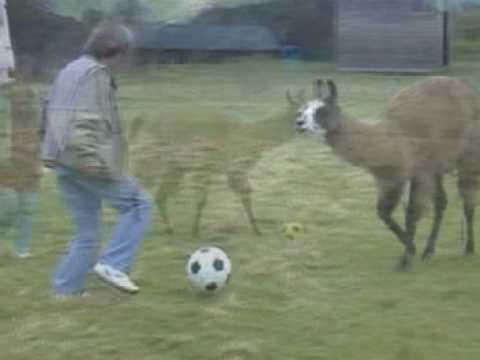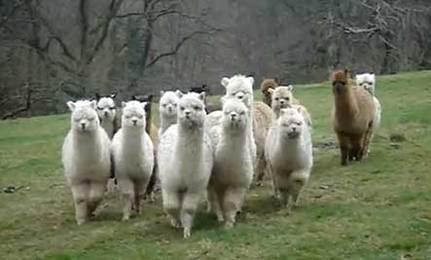The first image is the image on the left, the second image is the image on the right. Examine the images to the left and right. Is the description "One image shows a person in blue pants standing to the left of a brown llama, with a soccer ball on the ground between them." accurate? Answer yes or no. Yes. The first image is the image on the left, the second image is the image on the right. For the images shown, is this caption "In one of the images, there is a soccer ball between a person and a llama." true? Answer yes or no. Yes. 